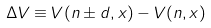<formula> <loc_0><loc_0><loc_500><loc_500>\Delta V \equiv V ( n \pm d , x ) - V ( n , x )</formula> 